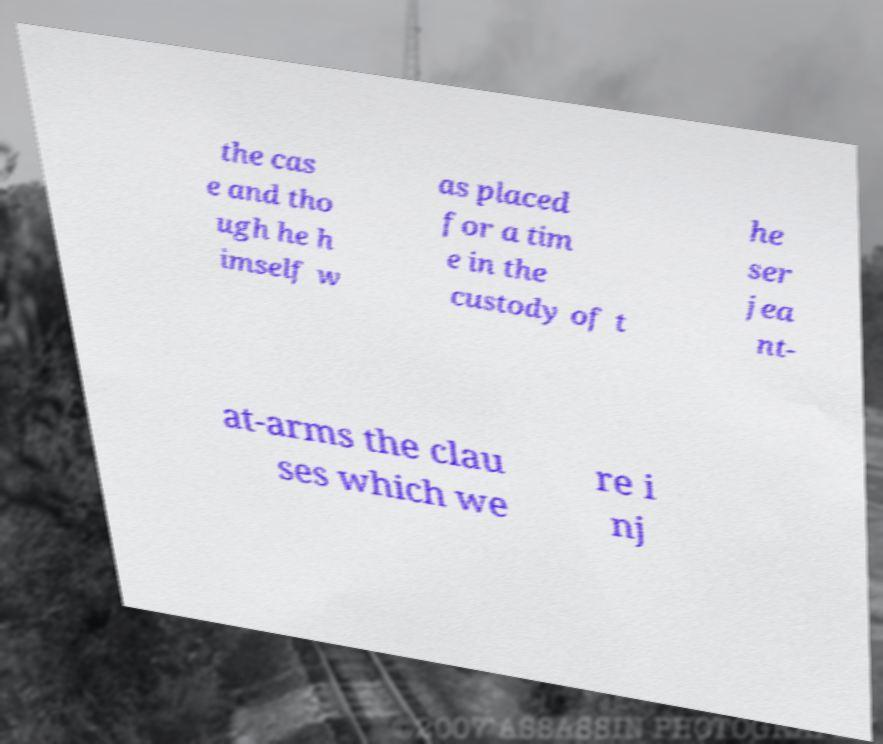For documentation purposes, I need the text within this image transcribed. Could you provide that? the cas e and tho ugh he h imself w as placed for a tim e in the custody of t he ser jea nt- at-arms the clau ses which we re i nj 